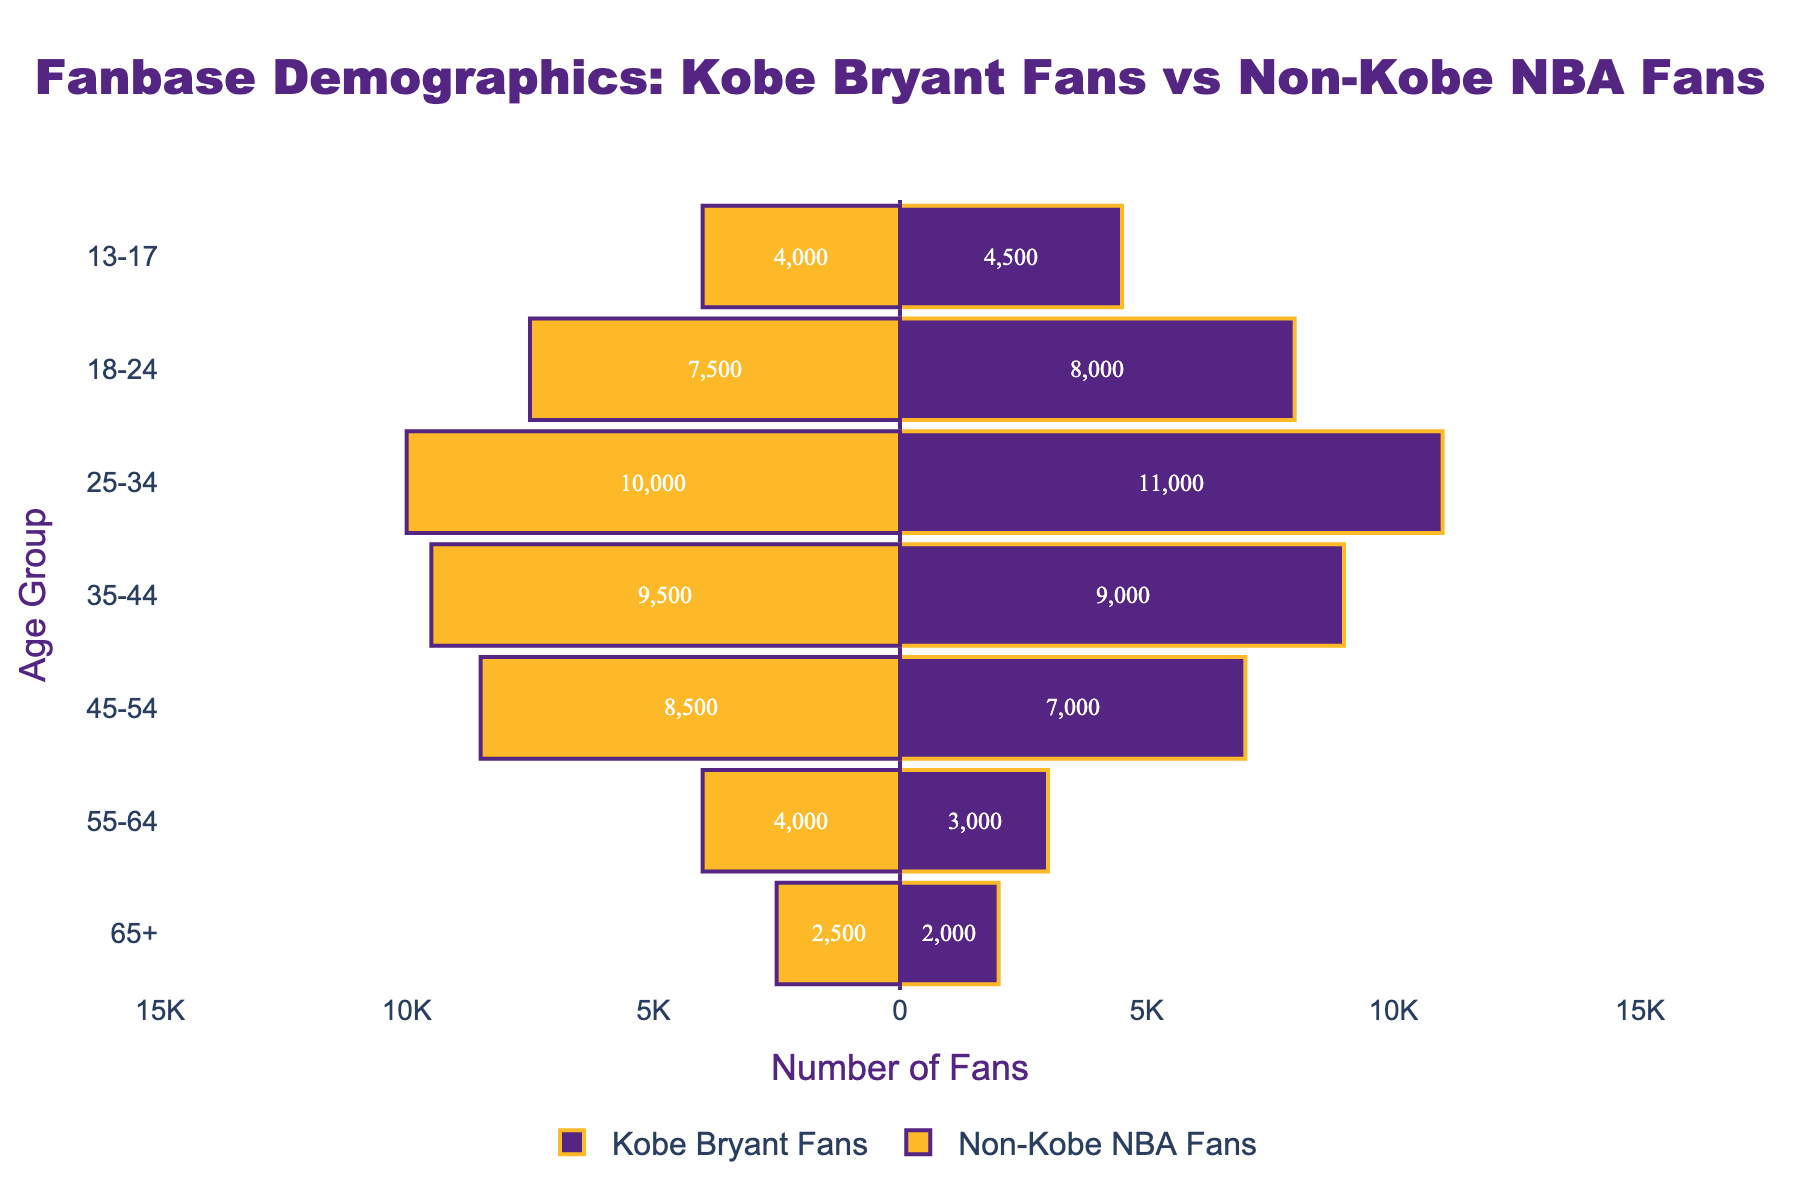Which age group has the highest number of Kobe Bryant fans? By closely examining the lengths of the bars for Kobe Bryant fans, we see that the age group "25-34" has the longest bar, indicating the highest number of fans.
Answer: 25-34 How many more fans does Kobe Bryant have in the 25-34 age group compared to the 13-17 age group? The number of Kobe Bryant fans in the 25-34 age group is 11,000, and in the 13-17 age group, it is 4,500. The difference is calculated as 11,000 - 4,500 = 6,500.
Answer: 6,500 Between which age groups is the difference between Kobe Bryant fans and Non-Kobe NBA fans the largest? We need to compare the absolute differences between Kobe Bryant fans and Non-Kobe NBA fans for each age group. The difference is largest in the "25-34" age group where the difference is 11,000 - 10,000 = 1,000.
Answer: 25-34 What is the total number of Kobe Bryant fans across all age groups? Sum the number of Kobe Bryant fans across all age groups: 4,500 + 8,000 + 11,000 + 9,000 + 7,000 + 3,000 + 2,000 = 44,500.
Answer: 44,500 Which age group has more Non-Kobe NBA fans compared to Kobe Bryant fans? By examining the bars, we find that the only age group where the Non-Kobe NBA fans bar extends further to the left is the 35-44 age group with 9,500 Non-Kobe NBA fans compared to 9,000 Kobe Bryant fans.
Answer: 35-44 What is the ratio of Kobe Bryant fans to Non-Kobe NBA fans in the 18-24 age group? The number of Kobe Bryant fans in the 18-24 age group is 8,000, and the number of Non-Kobe NBA fans is 7,500. The ratio is 8,000 / 7,500 = 1.07.
Answer: 1.07 In which age groups does the number of Kobe Bryant fans exceed Non-Kobe NBA fans? The age groups where the Kobe Bryant fans' bars exceed the Non-Kobe NBA fans' bars include 13-17, 18-24, 25-34, and 55-64.
Answer: 13-17, 18-24, 25-34, 55-64 Which age group has the smallest total fanbase when combining both Kobe Bryant fans and Non-Kobe NBA fans? Calculate the total fanbase for each age group and compare. For 65+, it is 2,000 (Kobe Bryant fans) + 2,500 (Non-Kobe NBA fans) = 4,500, which is the smallest total.
Answer: 65+ Are there more Kobe Bryant fans or Non-Kobe NBA fans in the 45-54 age group? By looking at the bar lengths, Non-Kobe NBA fans outnumber Kobe Bryant fans in the 45-54 age group with 8,500 fans compared to 7,000 fans for Kobe Bryant.
Answer: Non-Kobe NBA fans How does the number of Kobe Bryant fans in the 35-44 age group compare to the number in the 55-64 age group? The number of Kobe Bryant fans in the 35-44 age group is 9,000, and in the 55-64 age group, it is 3,000. Comparing these, 9,000 is greater than 3,000.
Answer: 35-44 > 55-64 